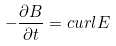<formula> <loc_0><loc_0><loc_500><loc_500>- \frac { \partial { B } } { \partial t } = c u r l { E }</formula> 